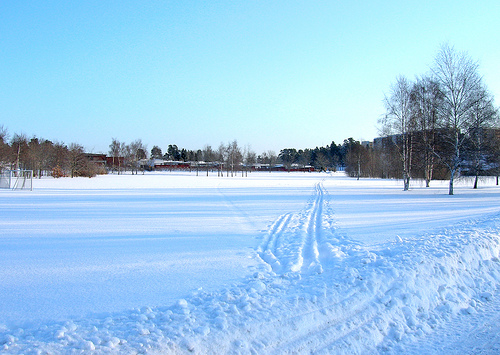<image>
Is the tree above the snow? No. The tree is not positioned above the snow. The vertical arrangement shows a different relationship. 